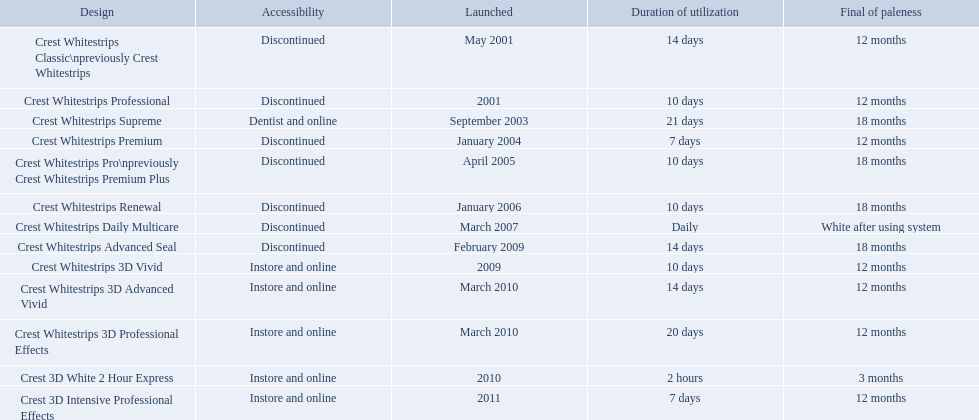What products are listed? Crest Whitestrips Classic\npreviously Crest Whitestrips, Crest Whitestrips Professional, Crest Whitestrips Supreme, Crest Whitestrips Premium, Crest Whitestrips Pro\npreviously Crest Whitestrips Premium Plus, Crest Whitestrips Renewal, Crest Whitestrips Daily Multicare, Crest Whitestrips Advanced Seal, Crest Whitestrips 3D Vivid, Crest Whitestrips 3D Advanced Vivid, Crest Whitestrips 3D Professional Effects, Crest 3D White 2 Hour Express, Crest 3D Intensive Professional Effects. Of these, which was were introduced in march, 2010? Crest Whitestrips 3D Advanced Vivid, Crest Whitestrips 3D Professional Effects. Of these, which were not 3d advanced vivid? Crest Whitestrips 3D Professional Effects. When was crest whitestrips 3d advanced vivid introduced? March 2010. What other product was introduced in march 2010? Crest Whitestrips 3D Professional Effects. What were the models of crest whitestrips? Crest Whitestrips Classic\npreviously Crest Whitestrips, Crest Whitestrips Professional, Crest Whitestrips Supreme, Crest Whitestrips Premium, Crest Whitestrips Pro\npreviously Crest Whitestrips Premium Plus, Crest Whitestrips Renewal, Crest Whitestrips Daily Multicare, Crest Whitestrips Advanced Seal, Crest Whitestrips 3D Vivid, Crest Whitestrips 3D Advanced Vivid, Crest Whitestrips 3D Professional Effects, Crest 3D White 2 Hour Express, Crest 3D Intensive Professional Effects. When were they introduced? May 2001, 2001, September 2003, January 2004, April 2005, January 2006, March 2007, February 2009, 2009, March 2010, March 2010, 2010, 2011. And what is their availability? Discontinued, Discontinued, Dentist and online, Discontinued, Discontinued, Discontinued, Discontinued, Discontinued, Instore and online, Instore and online, Instore and online, Instore and online, Instore and online. Along crest whitestrips 3d vivid, which discontinued model was released in 2009? Crest Whitestrips Advanced Seal. 